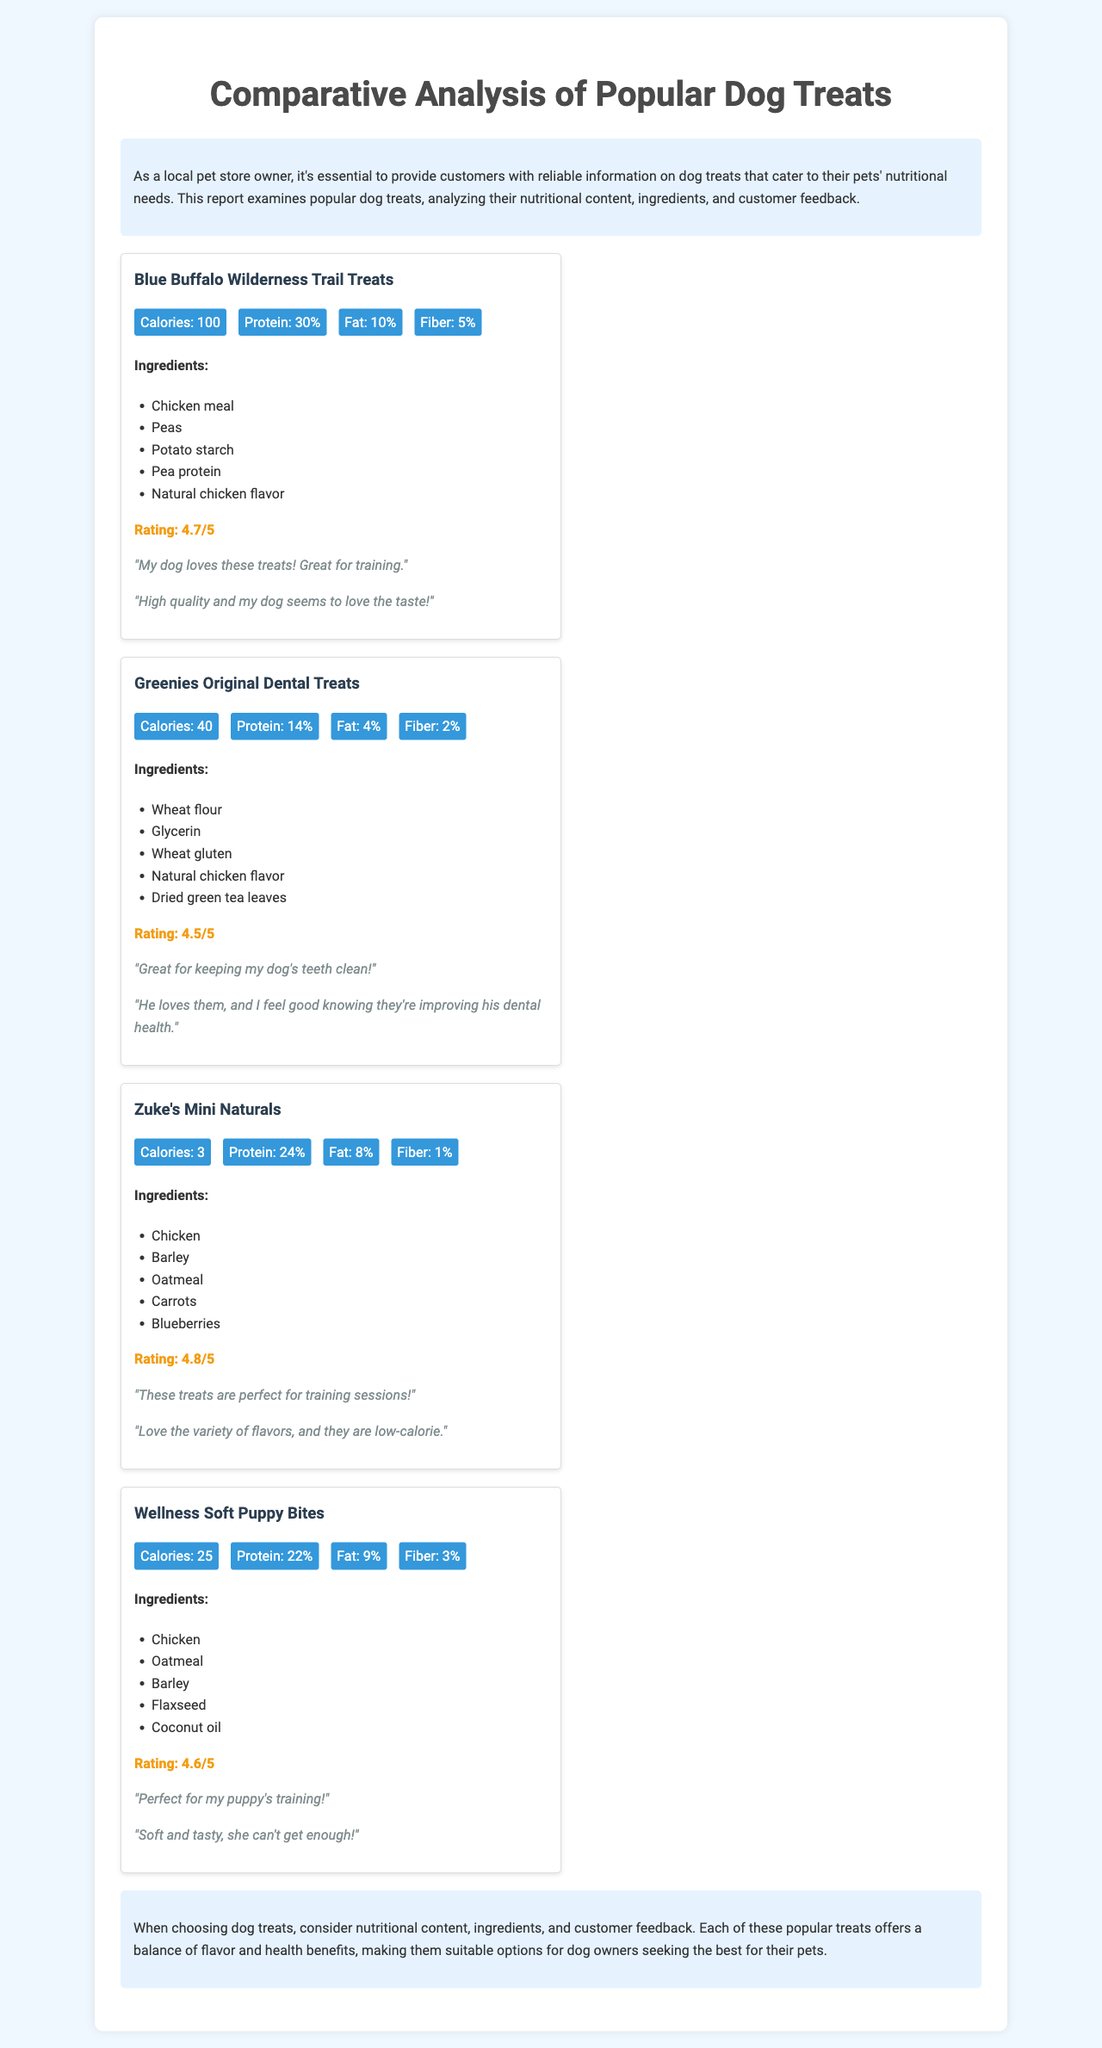What is the rating of Blue Buffalo Wilderness Trail Treats? The rating of Blue Buffalo Wilderness Trail Treats is mentioned in the feedback section of the document as 4.7/5.
Answer: 4.7/5 What is the primary ingredient in Zuke's Mini Naturals? The primary ingredient in Zuke's Mini Naturals is listed first in the ingredients section as Chicken.
Answer: Chicken How many calories are in Greenies Original Dental Treats? The calories are stated in the nutrition section of the document, which shows 40 calories.
Answer: 40 Which treat contains the highest protein percentage? The protein percentages are compared, and Blue Buffalo Wilderness Trail Treats has the highest at 30%.
Answer: 30% What fiber content does Wellness Soft Puppy Bites have? The fiber content for Wellness Soft Puppy Bites is provided in the nutrition section, showing it has 3%.
Answer: 3% Which treat is recommended for puppy training? The conclusion mentions that Wellness Soft Puppy Bites are "Perfect for my puppy's training!" indicating it is recommended for that purpose.
Answer: Wellness Soft Puppy Bites What is the total protein percentage for Zuke's Mini Naturals? The nutrition section specifically indicates that Zuke's Mini Naturals contains 24% protein.
Answer: 24% Which dog treat is best for dental health based on customer feedback? Greenies Original Dental Treats are highlighted in the feedback section as being great for keeping a dog's teeth clean.
Answer: Greenies Original Dental Treats 